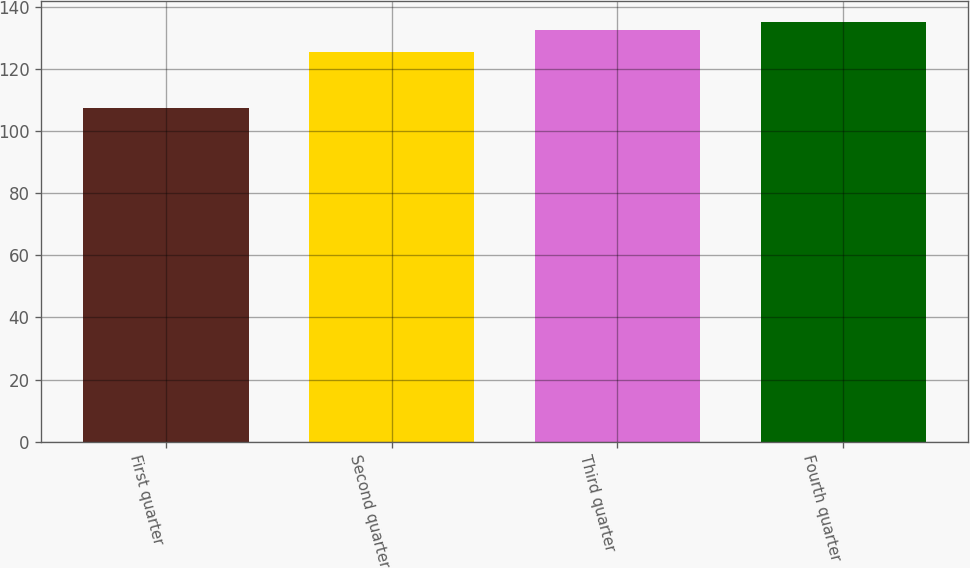<chart> <loc_0><loc_0><loc_500><loc_500><bar_chart><fcel>First quarter<fcel>Second quarter<fcel>Third quarter<fcel>Fourth quarter<nl><fcel>107.51<fcel>125.26<fcel>132.39<fcel>134.94<nl></chart> 